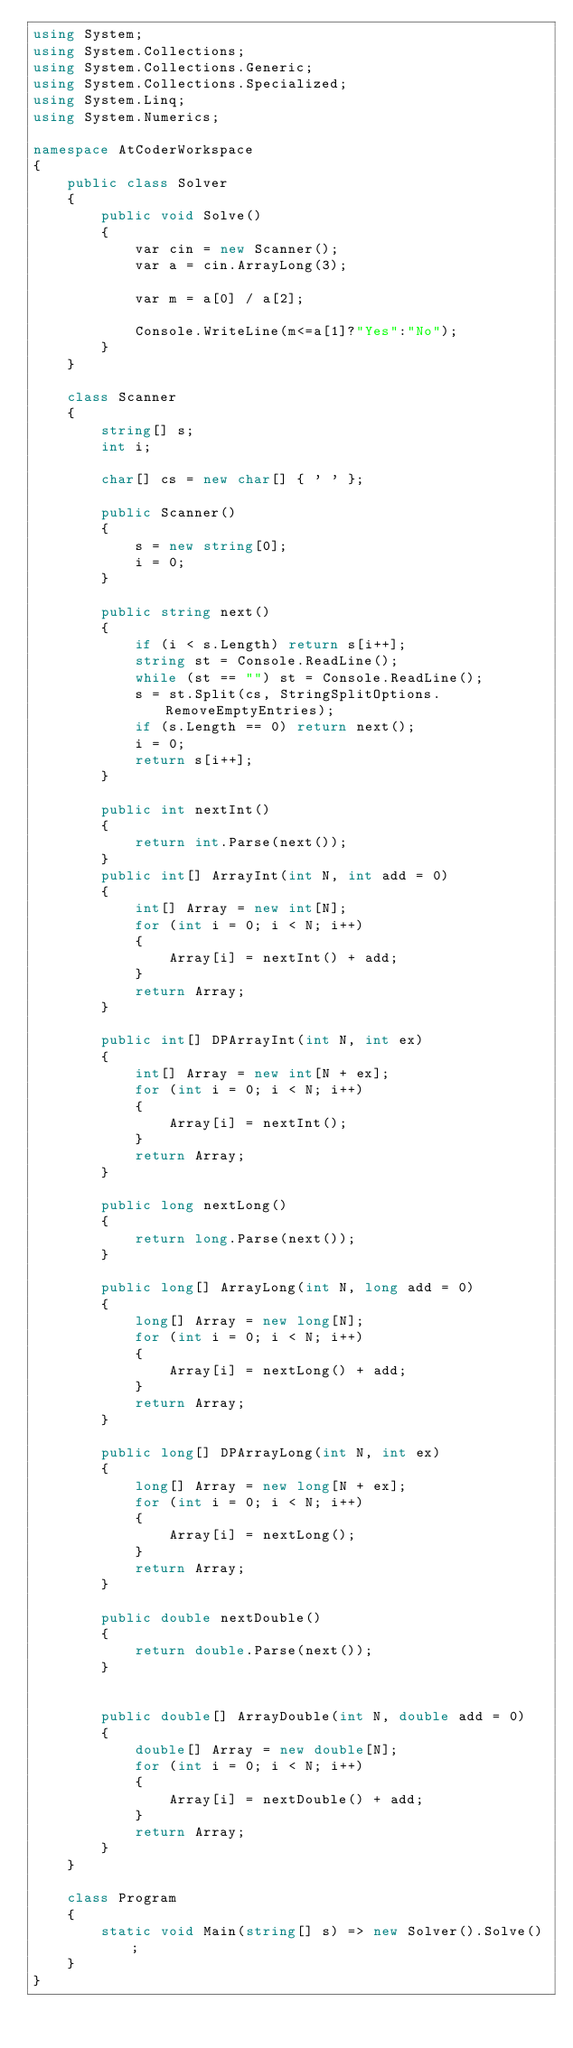Convert code to text. <code><loc_0><loc_0><loc_500><loc_500><_C#_>using System;
using System.Collections;
using System.Collections.Generic;
using System.Collections.Specialized;
using System.Linq;
using System.Numerics;

namespace AtCoderWorkspace
{
    public class Solver
    {
        public void Solve()
        {
            var cin = new Scanner();
            var a = cin.ArrayLong(3);

            var m = a[0] / a[2];
            
            Console.WriteLine(m<=a[1]?"Yes":"No");
        }
    }

    class Scanner
    {
        string[] s;
        int i;

        char[] cs = new char[] { ' ' };

        public Scanner()
        {
            s = new string[0];
            i = 0;
        }

        public string next()
        {
            if (i < s.Length) return s[i++];
            string st = Console.ReadLine();
            while (st == "") st = Console.ReadLine();
            s = st.Split(cs, StringSplitOptions.RemoveEmptyEntries);
            if (s.Length == 0) return next();
            i = 0;
            return s[i++];
        }

        public int nextInt()
        {
            return int.Parse(next());
        }
        public int[] ArrayInt(int N, int add = 0)
        {
            int[] Array = new int[N];
            for (int i = 0; i < N; i++)
            {
                Array[i] = nextInt() + add;
            }
            return Array;
        }

        public int[] DPArrayInt(int N, int ex)
        {
            int[] Array = new int[N + ex];
            for (int i = 0; i < N; i++)
            {
                Array[i] = nextInt();
            }
            return Array;
        }

        public long nextLong()
        {
            return long.Parse(next());
        }

        public long[] ArrayLong(int N, long add = 0)
        {
            long[] Array = new long[N];
            for (int i = 0; i < N; i++)
            {
                Array[i] = nextLong() + add;
            }
            return Array;
        }

        public long[] DPArrayLong(int N, int ex)
        {
            long[] Array = new long[N + ex];
            for (int i = 0; i < N; i++)
            {
                Array[i] = nextLong();
            }
            return Array;
        }

        public double nextDouble()
        {
            return double.Parse(next());
        }


        public double[] ArrayDouble(int N, double add = 0)
        {
            double[] Array = new double[N];
            for (int i = 0; i < N; i++)
            {
                Array[i] = nextDouble() + add;
            }
            return Array;
        }
    }

    class Program
    {
        static void Main(string[] s) => new Solver().Solve();
    }
}
</code> 